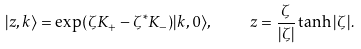Convert formula to latex. <formula><loc_0><loc_0><loc_500><loc_500>| z , k \rangle = \exp ( \zeta K _ { + } - \zeta ^ { \ast } K _ { - } ) | k , 0 \rangle , \quad z = \frac { \zeta } { | \zeta | } \tanh | \zeta | .</formula> 